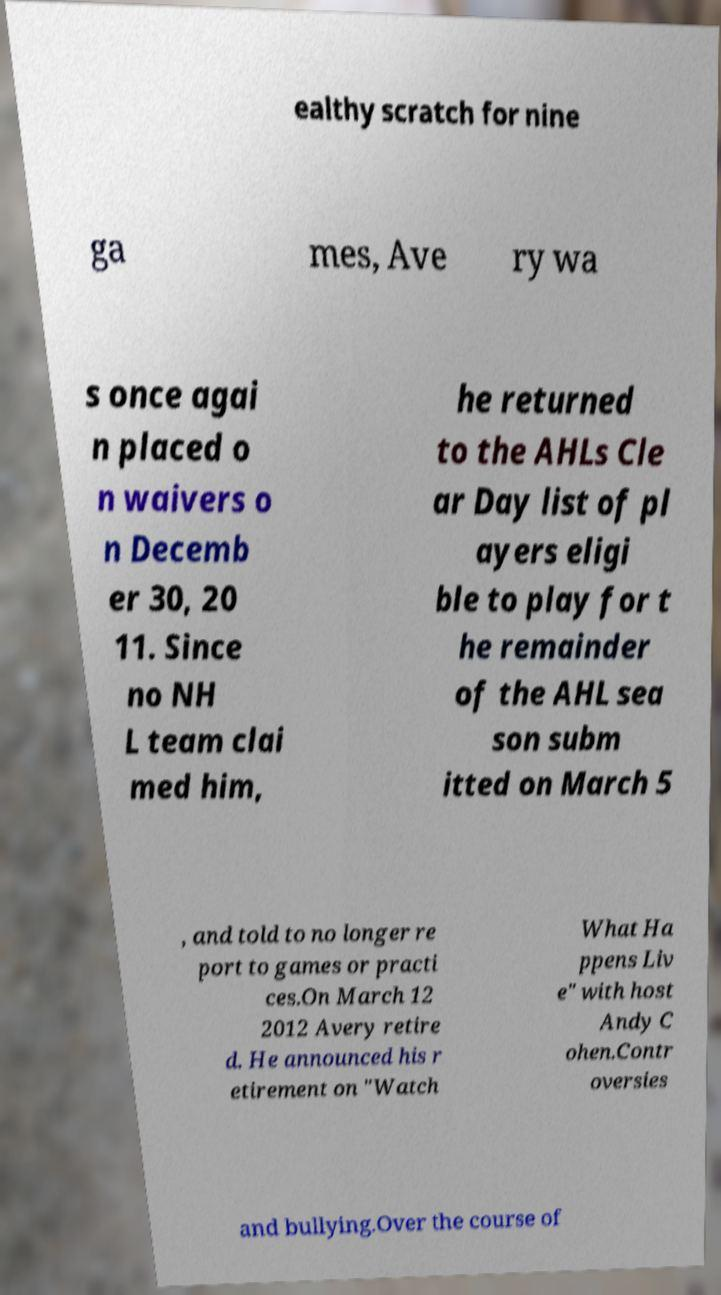Could you assist in decoding the text presented in this image and type it out clearly? ealthy scratch for nine ga mes, Ave ry wa s once agai n placed o n waivers o n Decemb er 30, 20 11. Since no NH L team clai med him, he returned to the AHLs Cle ar Day list of pl ayers eligi ble to play for t he remainder of the AHL sea son subm itted on March 5 , and told to no longer re port to games or practi ces.On March 12 2012 Avery retire d. He announced his r etirement on "Watch What Ha ppens Liv e" with host Andy C ohen.Contr oversies and bullying.Over the course of 